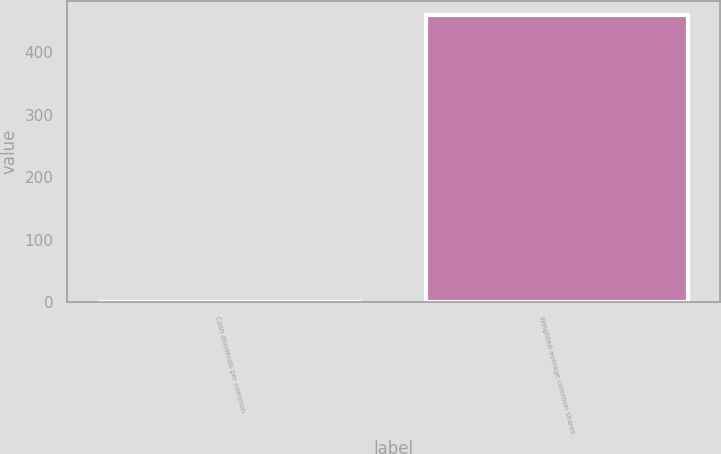Convert chart to OTSL. <chart><loc_0><loc_0><loc_500><loc_500><bar_chart><fcel>Cash dividends per common<fcel>Weighted average common shares<nl><fcel>0.67<fcel>458.73<nl></chart> 